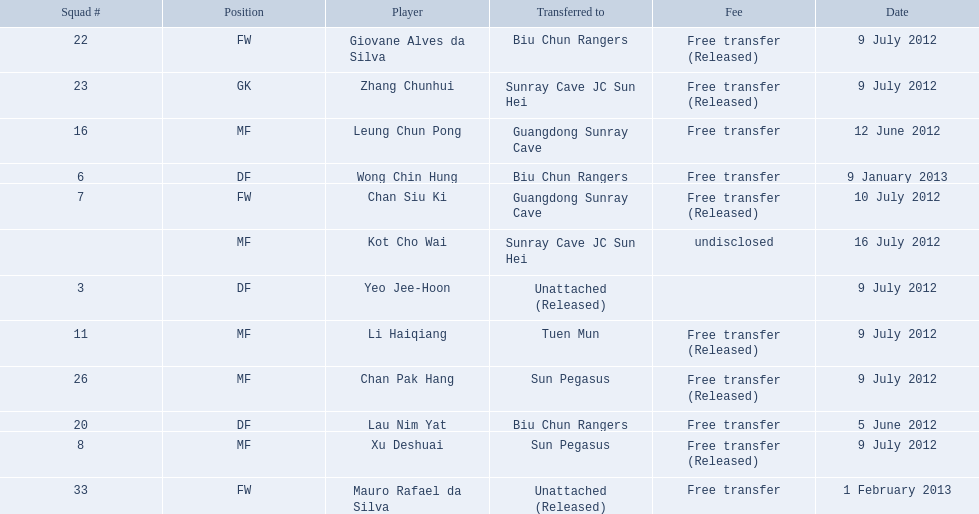Which players played during the 2012-13 south china aa season? Lau Nim Yat, Leung Chun Pong, Yeo Jee-Hoon, Xu Deshuai, Li Haiqiang, Giovane Alves da Silva, Zhang Chunhui, Chan Pak Hang, Chan Siu Ki, Kot Cho Wai, Wong Chin Hung, Mauro Rafael da Silva. Of these, which were free transfers that were not released? Lau Nim Yat, Leung Chun Pong, Wong Chin Hung, Mauro Rafael da Silva. Of these, which were in squad # 6? Wong Chin Hung. What was the date of his transfer? 9 January 2013. 